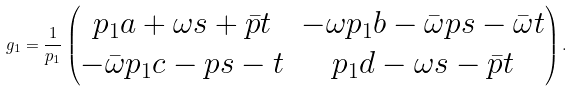<formula> <loc_0><loc_0><loc_500><loc_500>g _ { 1 } = \frac { 1 } { p _ { 1 } } \begin{pmatrix} p _ { 1 } a + \omega s + \bar { p } t & - \omega p _ { 1 } b - \bar { \omega } p s - \bar { \omega } t \\ - \bar { \omega } p _ { 1 } c - p s - t & p _ { 1 } d - \omega s - \bar { p } t \end{pmatrix} .</formula> 